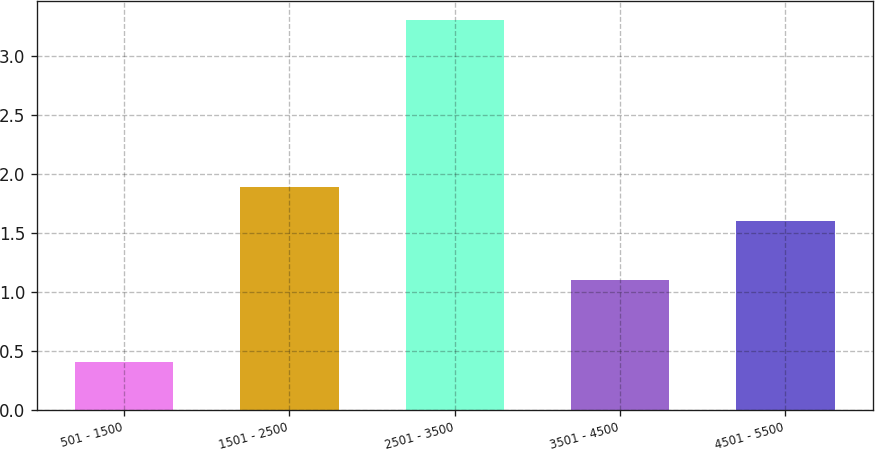Convert chart. <chart><loc_0><loc_0><loc_500><loc_500><bar_chart><fcel>501 - 1500<fcel>1501 - 2500<fcel>2501 - 3500<fcel>3501 - 4500<fcel>4501 - 5500<nl><fcel>0.4<fcel>1.89<fcel>3.3<fcel>1.1<fcel>1.6<nl></chart> 